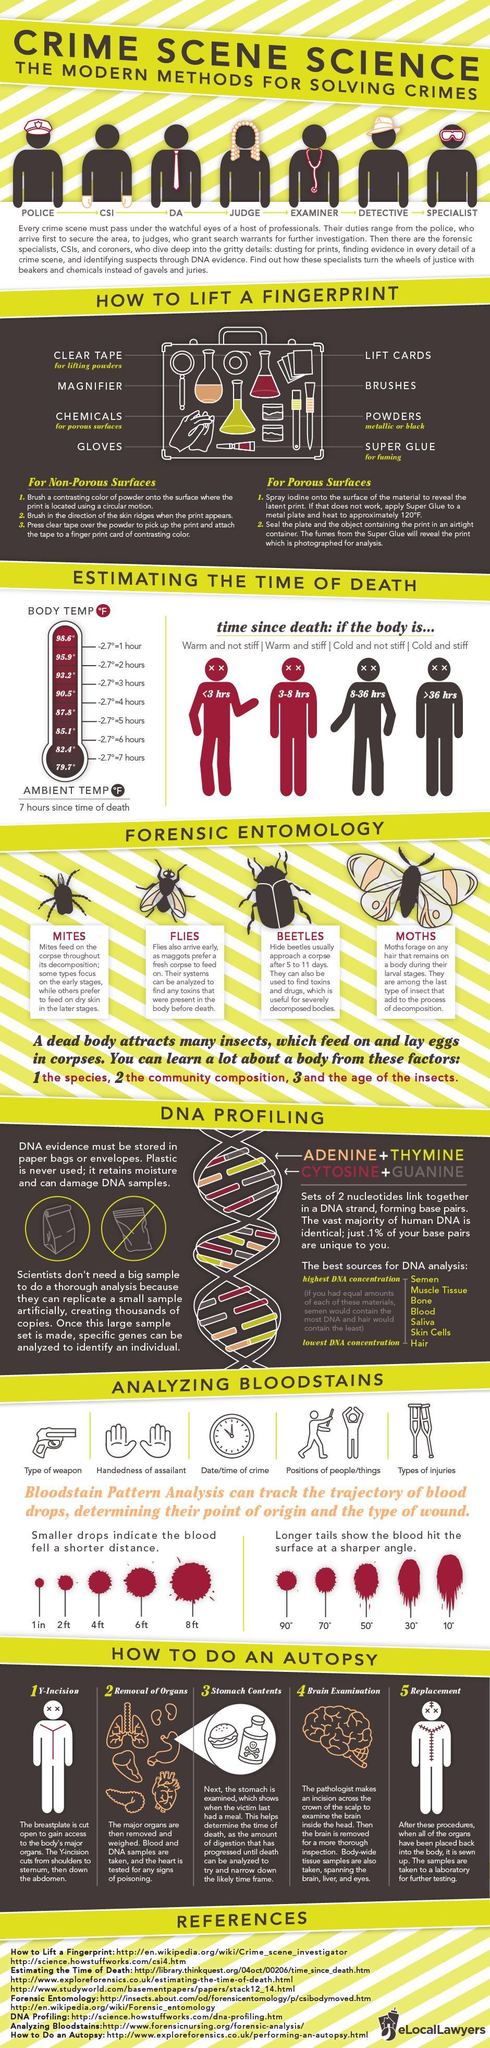Who arrives second at a crime scene?
Answer the question with a short phrase. CSI What happens to a body after 36 hours since the death? Cold and stiff How many hours passed since the time of death if the body temperature is at 95.9°F? 2 hours Who arrives first at a crime scene? POLICE How many hours passed since the time of death if the body is warm & stiff? 3-8 hrs What surfaces can superglue fuming be used on? Porous Surfaces What happens to a body in the first three hours of death? Warm and not stiff What is the final step in an autopsy? Replacement 